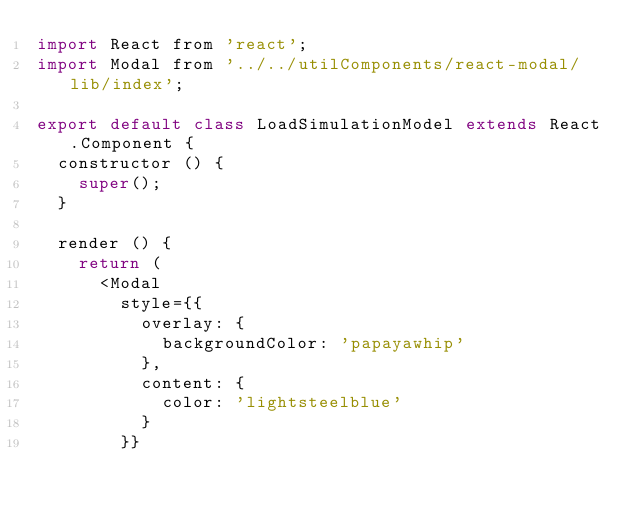<code> <loc_0><loc_0><loc_500><loc_500><_JavaScript_>import React from 'react';
import Modal from '../../utilComponents/react-modal/lib/index';

export default class LoadSimulationModel extends React.Component {
	constructor () {
		super();
	}

	render () {
		return (
			<Modal
				style={{
					overlay: {
						backgroundColor: 'papayawhip'
					},
					content: {
						color: 'lightsteelblue'
					}
				}}</code> 